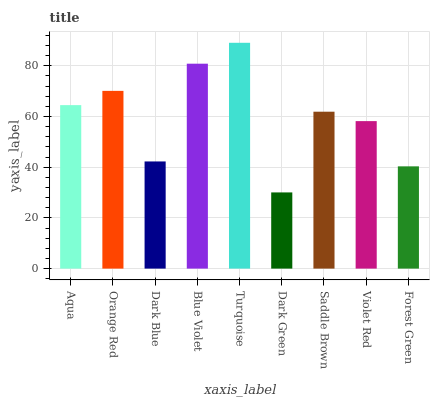Is Dark Green the minimum?
Answer yes or no. Yes. Is Turquoise the maximum?
Answer yes or no. Yes. Is Orange Red the minimum?
Answer yes or no. No. Is Orange Red the maximum?
Answer yes or no. No. Is Orange Red greater than Aqua?
Answer yes or no. Yes. Is Aqua less than Orange Red?
Answer yes or no. Yes. Is Aqua greater than Orange Red?
Answer yes or no. No. Is Orange Red less than Aqua?
Answer yes or no. No. Is Saddle Brown the high median?
Answer yes or no. Yes. Is Saddle Brown the low median?
Answer yes or no. Yes. Is Orange Red the high median?
Answer yes or no. No. Is Blue Violet the low median?
Answer yes or no. No. 